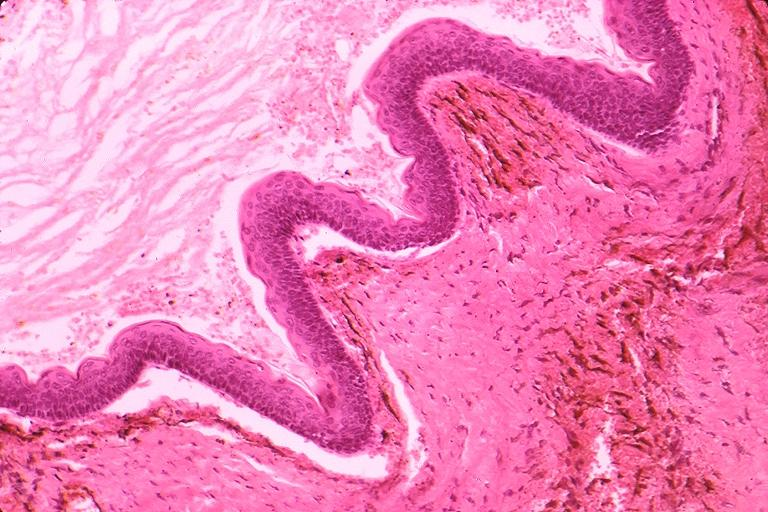does this image show odontogenic keratocyst?
Answer the question using a single word or phrase. Yes 